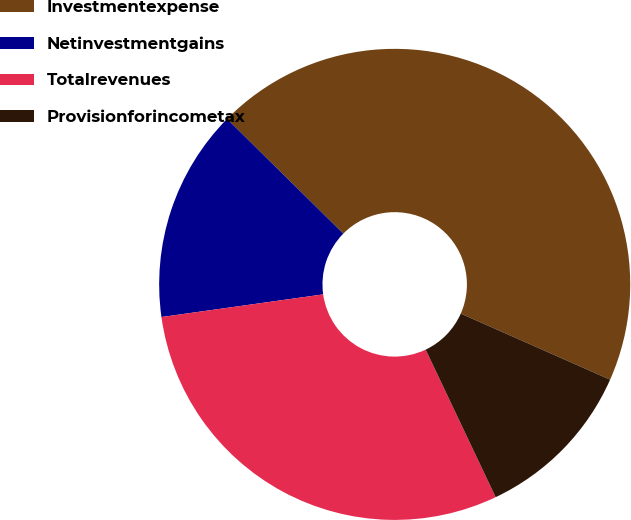<chart> <loc_0><loc_0><loc_500><loc_500><pie_chart><fcel>Investmentexpense<fcel>Netinvestmentgains<fcel>Totalrevenues<fcel>Provisionforincometax<nl><fcel>44.24%<fcel>14.61%<fcel>29.84%<fcel>11.32%<nl></chart> 